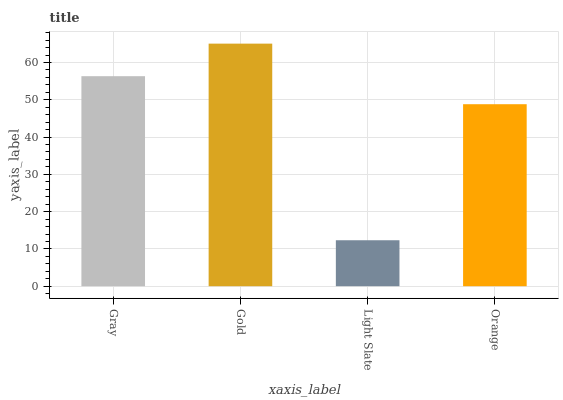Is Light Slate the minimum?
Answer yes or no. Yes. Is Gold the maximum?
Answer yes or no. Yes. Is Gold the minimum?
Answer yes or no. No. Is Light Slate the maximum?
Answer yes or no. No. Is Gold greater than Light Slate?
Answer yes or no. Yes. Is Light Slate less than Gold?
Answer yes or no. Yes. Is Light Slate greater than Gold?
Answer yes or no. No. Is Gold less than Light Slate?
Answer yes or no. No. Is Gray the high median?
Answer yes or no. Yes. Is Orange the low median?
Answer yes or no. Yes. Is Gold the high median?
Answer yes or no. No. Is Gray the low median?
Answer yes or no. No. 